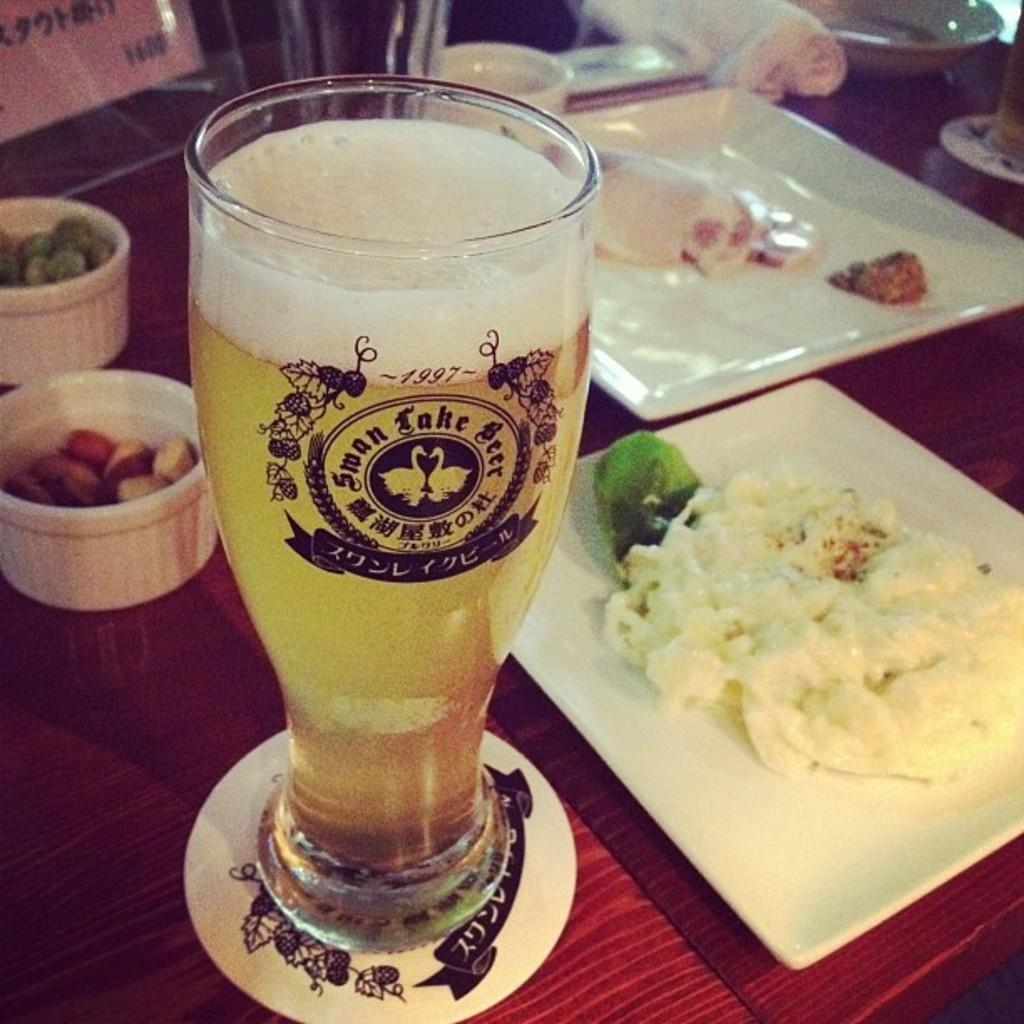What types of containers are holding food items in the image? There are plates and bowls holding food items in the image. What beverage is visible in the image? There is a glass of wine in the image. What else can be seen on the table in the image? There are objects on the table in the image. Can you see the ear of the person taking the picture in the image? There is no person taking a picture in the image, and therefore no ear is visible. 